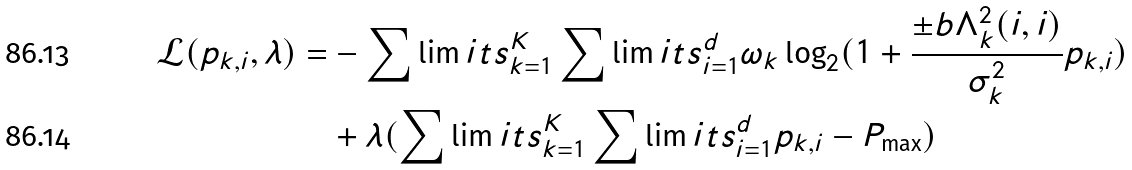Convert formula to latex. <formula><loc_0><loc_0><loc_500><loc_500>\mathcal { L } ( p _ { k , i } , \lambda ) = & - \sum \lim i t s _ { k = 1 } ^ { K } \sum \lim i t s _ { i = 1 } ^ { d } \omega _ { k } \log _ { 2 } ( 1 + \frac { \pm b { \Lambda } _ { k } ^ { 2 } ( i , i ) } { \sigma _ { k } ^ { 2 } } p _ { k , i } ) \\ & + \lambda ( \sum \lim i t s _ { k = 1 } ^ { K } \sum \lim i t s _ { i = 1 } ^ { d } p _ { k , i } - P _ { \max } )</formula> 